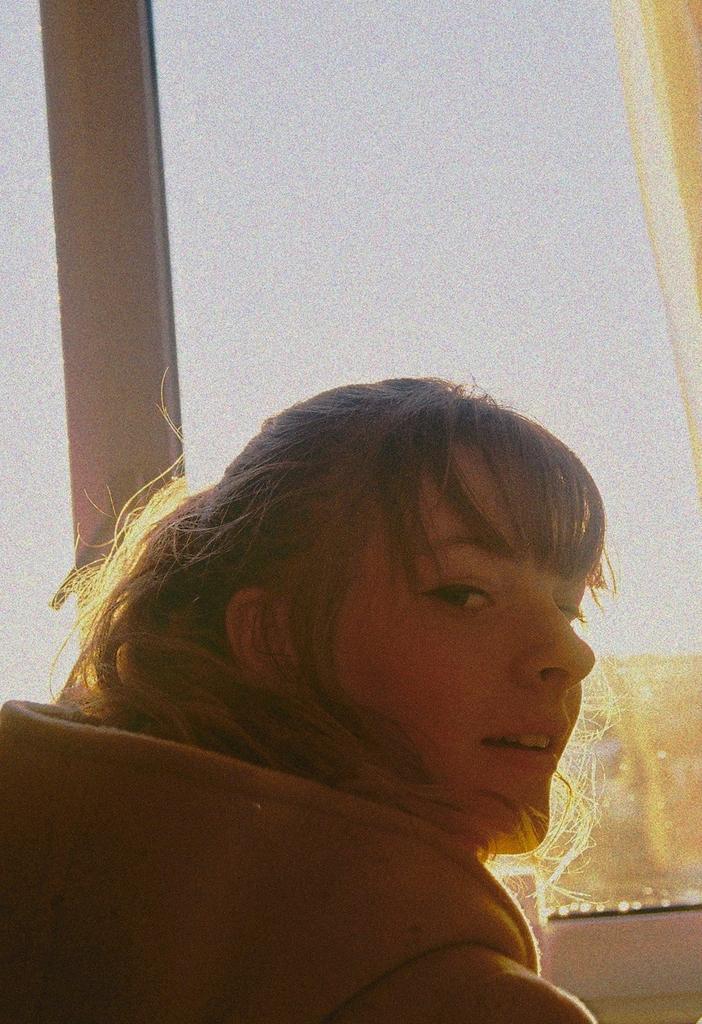Please provide a concise description of this image. In this picture we can see a woman wearing a jacket and smiling, curtain, glass and from the glass we can see some objects, sky. 